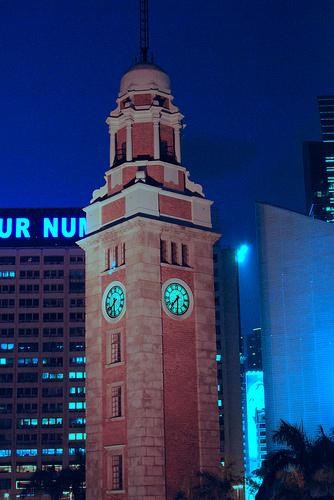Briefly describe the text and signage present in the image. There are illuminated letters and a neon sign featured on one of the buildings, adding a vivid touch to the nighttime scene. Mention the primary architectural elements present in the image. The image includes a tall brick clock tower with a small dome, stone columns, ledges, and windows, as well as nearby buildings with lit windows and neon signs. Write a sentence about the lighting in the image. The image displays various sources of light, such as illuminated clock faces, lit windows, neon signs, and street lights. Mention the type of numerals found on the clock faces in the image. The clock faces on the tower showcase Roman numerals surrounding the illuminated dials. Describe the appearance of the clock tower in the image. The clock tower is red-bricked, tall, and has a small dome on top, featuring illuminated clock faces with Roman numerals and hands indicating 7:30. Briefly summarize the overall scene captured in the image. A photo of a brick clock tower at night, featuring illuminated clock faces, surrounding buildings with lit windows, and palm trees in the foreground. What is the setting of the image and the time of the day? The image is set in an urban area with buildings and a clock tower, and it appears to be nighttime as the sky is dark and windows are lit. What details can be observed about the windows in the image? There are windows with bars, lit windows, dark windows, and small windows under ledges in the clock tower and surrounding buildings. Describe the color and appearance of the sky in the image. Even though the sky is dark, suggesting nighttime, it remains a clear and blue expanse in the image. Explain the presence of trees in the image. Palm-like trees are visible in front of the right side of the clock tower, adding a touch of nature to the urban scene. 